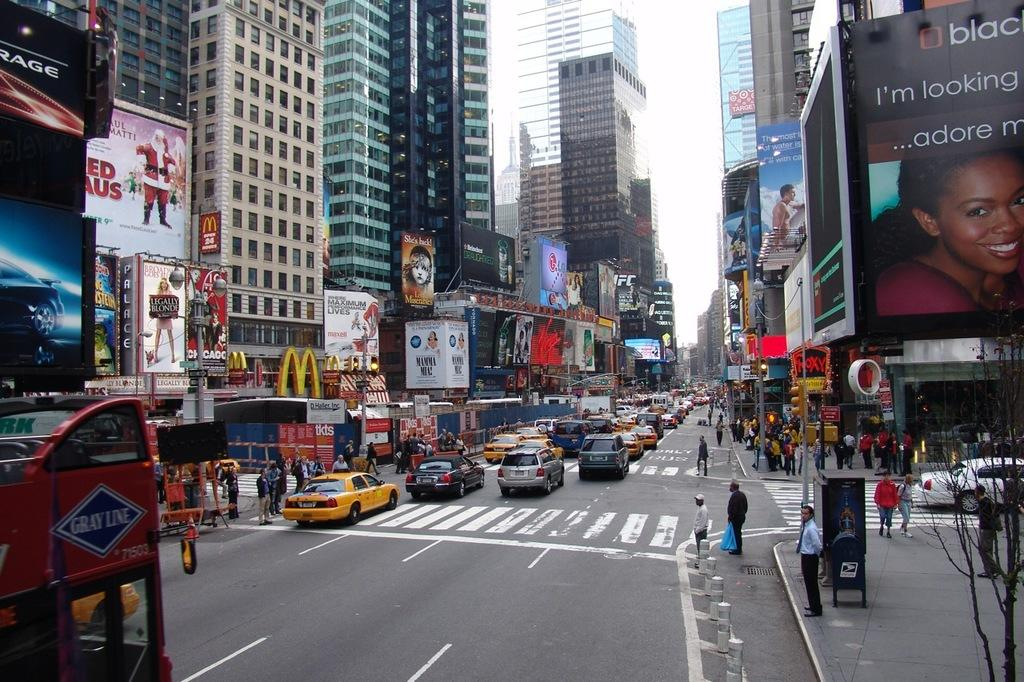Provide a one-sentence caption for the provided image. Busy New York street with a Grey Line bus on the left. 